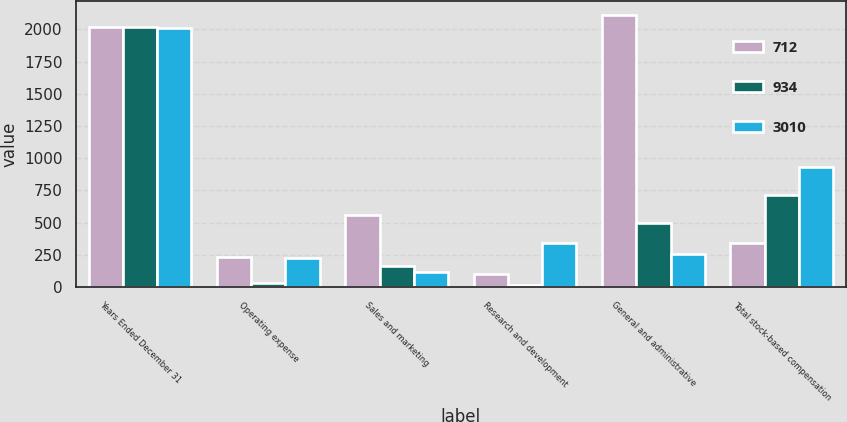Convert chart to OTSL. <chart><loc_0><loc_0><loc_500><loc_500><stacked_bar_chart><ecel><fcel>Years Ended December 31<fcel>Operating expense<fcel>Sales and marketing<fcel>Research and development<fcel>General and administrative<fcel>Total stock-based compensation<nl><fcel>712<fcel>2015<fcel>235<fcel>559<fcel>104<fcel>2112<fcel>345<nl><fcel>934<fcel>2014<fcel>32<fcel>166<fcel>16<fcel>498<fcel>712<nl><fcel>3010<fcel>2013<fcel>222<fcel>114<fcel>345<fcel>253<fcel>934<nl></chart> 